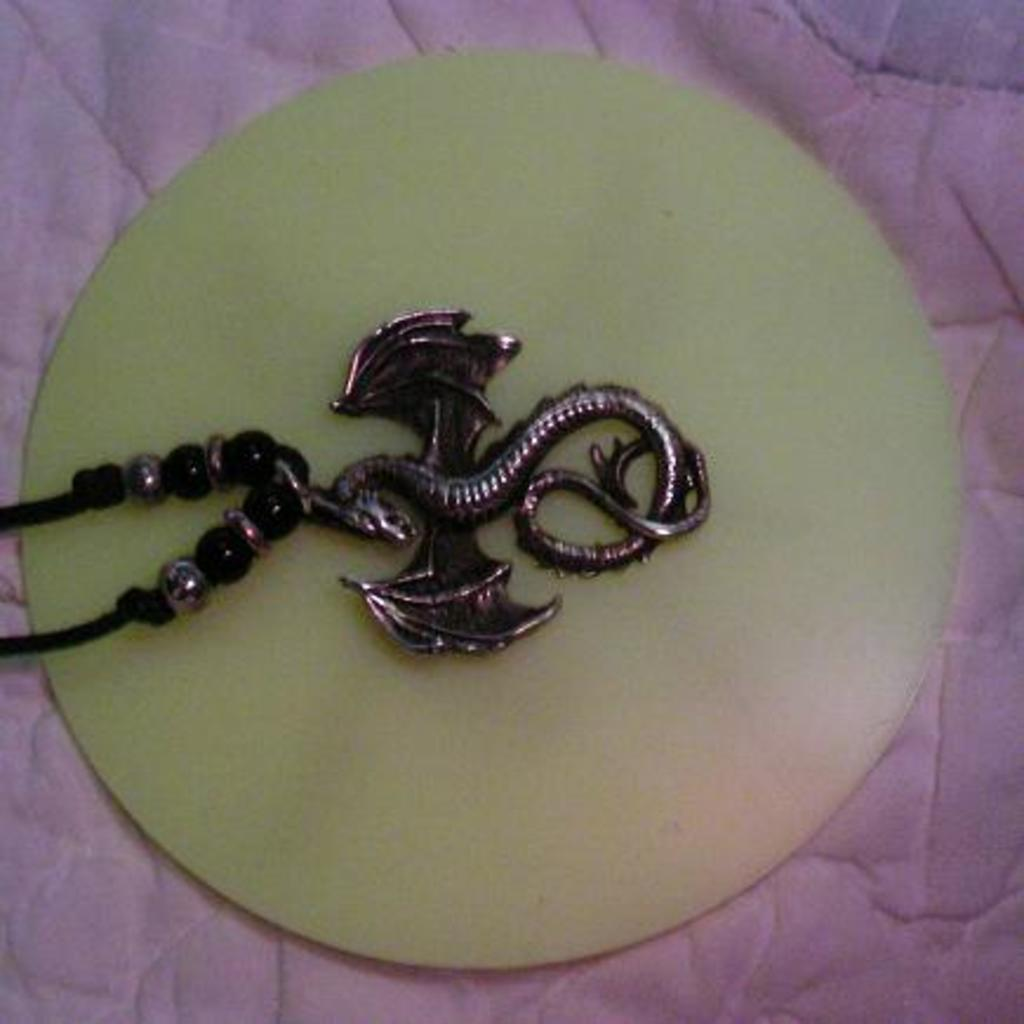What is the main object in the image? There is a chain in the image. What is the chain attached to? The chain is on a round glass-like object. What color is the cloth surrounding the object? There is a pink-colored cloth on the edges of the object. What language is spoken by the jeans in the image? There are no jeans present in the image, and therefore no language can be spoken by them. 